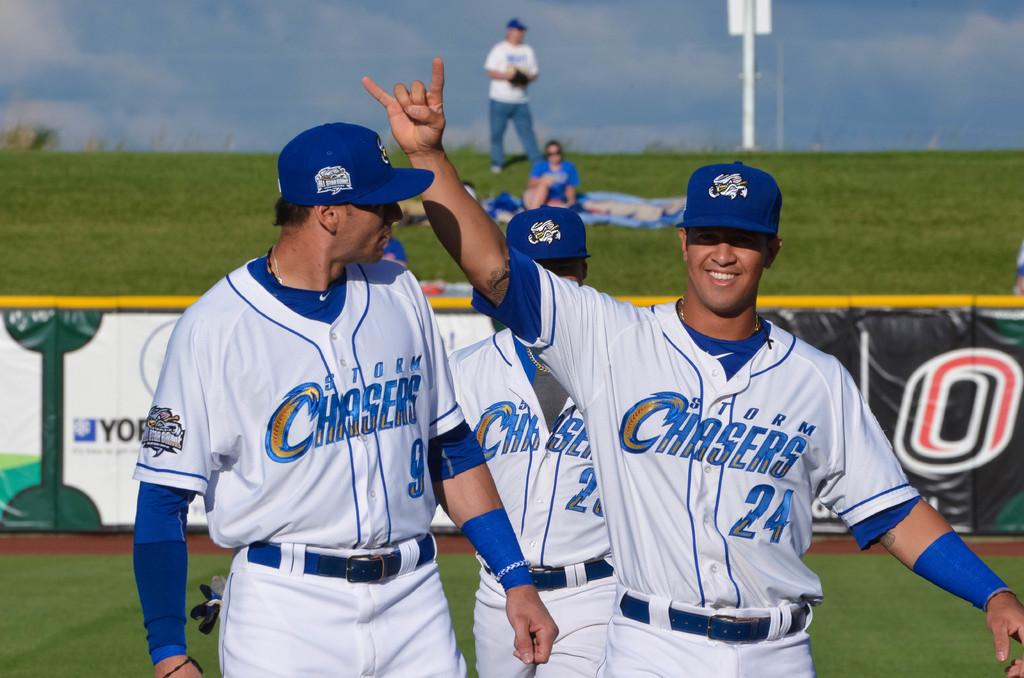<image>
Write a terse but informative summary of the picture. Baseball players from the Storm CHasers are walking on the baseball field. 